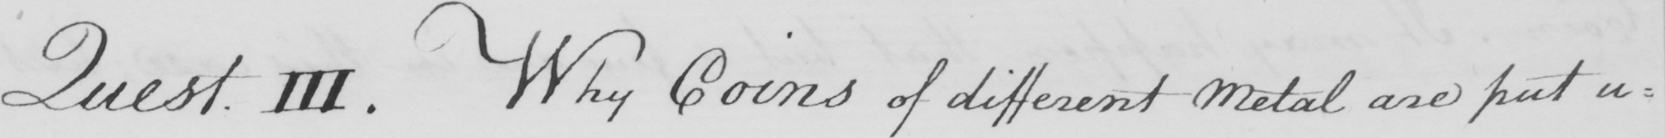What text is written in this handwritten line? Quest. III. Why Coins of different Metal are put u= 